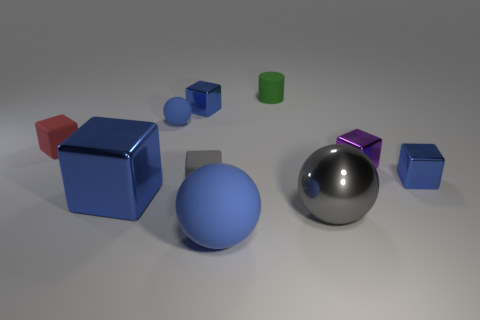What might be the purpose of this arrangement of objects? This arrangement might serve a variety of purposes. It could be a visual test for studying color and texture perception under different lighting conditions, an artist's study in composition and balance contrasting shapes and materials, or even a render test for a 3D modeling software, showcasing the program's capability to simulate different surfaces and lighting effects. 